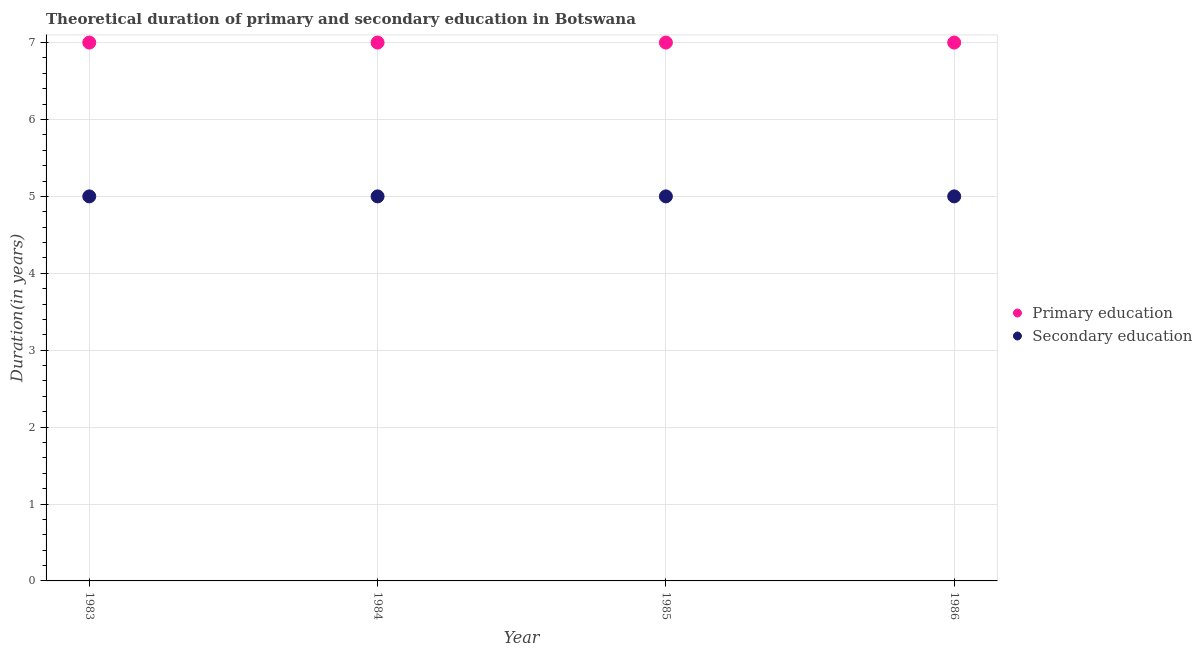How many different coloured dotlines are there?
Give a very brief answer. 2. Is the number of dotlines equal to the number of legend labels?
Ensure brevity in your answer.  Yes. What is the duration of primary education in 1986?
Your answer should be very brief. 7. Across all years, what is the maximum duration of primary education?
Your response must be concise. 7. Across all years, what is the minimum duration of primary education?
Offer a terse response. 7. In which year was the duration of secondary education maximum?
Provide a succinct answer. 1983. What is the total duration of primary education in the graph?
Provide a short and direct response. 28. What is the difference between the duration of secondary education in 1984 and that in 1986?
Provide a short and direct response. 0. What is the difference between the duration of secondary education in 1985 and the duration of primary education in 1983?
Offer a terse response. -2. In the year 1985, what is the difference between the duration of secondary education and duration of primary education?
Your answer should be very brief. -2. In how many years, is the duration of primary education greater than 4.8 years?
Your answer should be compact. 4. What is the ratio of the duration of primary education in 1983 to that in 1984?
Offer a terse response. 1. Is the duration of secondary education in 1984 less than that in 1986?
Offer a very short reply. No. Is the difference between the duration of primary education in 1983 and 1986 greater than the difference between the duration of secondary education in 1983 and 1986?
Provide a short and direct response. No. What is the difference between the highest and the second highest duration of primary education?
Make the answer very short. 0. In how many years, is the duration of secondary education greater than the average duration of secondary education taken over all years?
Your response must be concise. 0. Is the sum of the duration of primary education in 1983 and 1986 greater than the maximum duration of secondary education across all years?
Ensure brevity in your answer.  Yes. Does the duration of secondary education monotonically increase over the years?
Make the answer very short. No. Is the duration of secondary education strictly greater than the duration of primary education over the years?
Provide a short and direct response. No. Is the duration of primary education strictly less than the duration of secondary education over the years?
Your answer should be compact. No. How many dotlines are there?
Make the answer very short. 2. How many years are there in the graph?
Your answer should be very brief. 4. What is the difference between two consecutive major ticks on the Y-axis?
Give a very brief answer. 1. Are the values on the major ticks of Y-axis written in scientific E-notation?
Give a very brief answer. No. Does the graph contain any zero values?
Ensure brevity in your answer.  No. What is the title of the graph?
Provide a short and direct response. Theoretical duration of primary and secondary education in Botswana. Does "Automatic Teller Machines" appear as one of the legend labels in the graph?
Your answer should be very brief. No. What is the label or title of the X-axis?
Offer a very short reply. Year. What is the label or title of the Y-axis?
Offer a terse response. Duration(in years). What is the Duration(in years) in Secondary education in 1983?
Make the answer very short. 5. What is the Duration(in years) of Primary education in 1984?
Offer a very short reply. 7. What is the Duration(in years) in Secondary education in 1985?
Your response must be concise. 5. Across all years, what is the maximum Duration(in years) of Primary education?
Your answer should be very brief. 7. What is the difference between the Duration(in years) in Primary education in 1983 and that in 1984?
Keep it short and to the point. 0. What is the difference between the Duration(in years) of Secondary education in 1983 and that in 1985?
Keep it short and to the point. 0. What is the difference between the Duration(in years) in Primary education in 1983 and that in 1986?
Provide a succinct answer. 0. What is the difference between the Duration(in years) of Secondary education in 1984 and that in 1985?
Give a very brief answer. 0. What is the difference between the Duration(in years) in Primary education in 1983 and the Duration(in years) in Secondary education in 1984?
Your response must be concise. 2. What is the difference between the Duration(in years) of Primary education in 1983 and the Duration(in years) of Secondary education in 1986?
Provide a short and direct response. 2. What is the difference between the Duration(in years) of Primary education in 1984 and the Duration(in years) of Secondary education in 1985?
Your response must be concise. 2. In the year 1983, what is the difference between the Duration(in years) in Primary education and Duration(in years) in Secondary education?
Provide a succinct answer. 2. In the year 1986, what is the difference between the Duration(in years) in Primary education and Duration(in years) in Secondary education?
Provide a succinct answer. 2. What is the ratio of the Duration(in years) in Primary education in 1983 to that in 1984?
Offer a very short reply. 1. What is the ratio of the Duration(in years) of Primary education in 1983 to that in 1986?
Give a very brief answer. 1. What is the ratio of the Duration(in years) in Primary education in 1984 to that in 1986?
Your response must be concise. 1. What is the ratio of the Duration(in years) of Primary education in 1985 to that in 1986?
Your answer should be very brief. 1. What is the ratio of the Duration(in years) of Secondary education in 1985 to that in 1986?
Your response must be concise. 1. What is the difference between the highest and the second highest Duration(in years) in Primary education?
Offer a terse response. 0. What is the difference between the highest and the second highest Duration(in years) in Secondary education?
Your answer should be compact. 0. What is the difference between the highest and the lowest Duration(in years) in Primary education?
Ensure brevity in your answer.  0. What is the difference between the highest and the lowest Duration(in years) in Secondary education?
Offer a terse response. 0. 